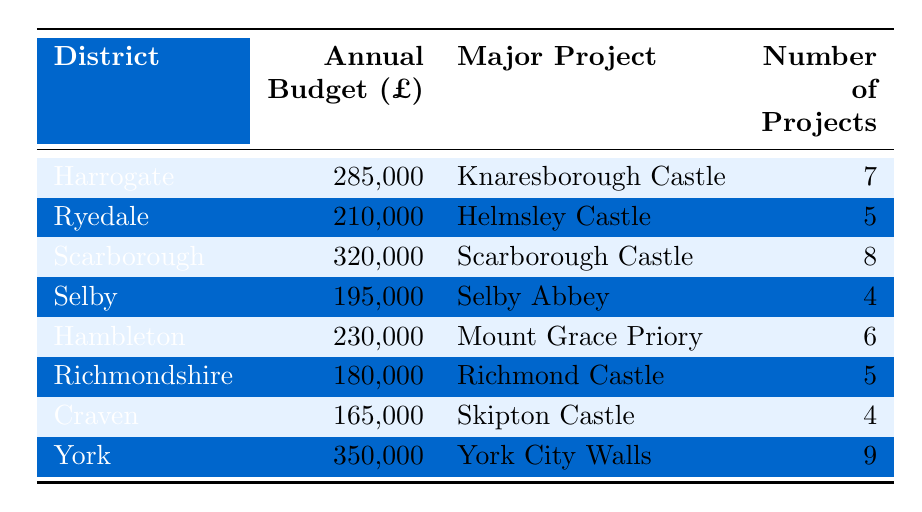What is the annual budget for the Scarborough district? The table lists Scarborough's annual budget as £320,000, which is directly indicated in the corresponding row for this district.
Answer: £320,000 Which district has the highest annual budget? York has the highest annual budget listed at £350,000, which can be confirmed by comparing all the budgets in the table.
Answer: York How many projects are allocated for the Selby district? The number of projects for Selby is stated in the table as 4, which is directly indicated next to the Selby row.
Answer: 4 What is the total annual budget for districts with major projects involving castles? Add the annual budgets of Harrogate (£285,000), Ryedale (£210,000), Scarborough (£320,000), Hambleton (£230,000), Richmondshire (£180,000), Craven (£165,000), and York (£350,000). The total is £285,000 + £210,000 + £320,000 + £230,000 + £180,000 + £165,000 + £350,000 = £1,740,000.
Answer: £1,740,000 Do any districts have the same number of projects? Yes, both Richmondshire and Craven have 5 projects each, as noted in the number of projects column which shows these values for both districts.
Answer: Yes What is the average annual budget for all the districts listed? To find the average, sum the budgets (£285,000 + £210,000 + £320,000 + £195,000 + £230,000 + £180,000 + £165,000 + £350,000 = £1,735,000) and then divide by the number of districts (8). The average annual budget is £1,735,000 / 8 = £216,875.
Answer: £216,875 Which district has the lowest annual budget, and what is it? Looking at the budgets, Richmondshire has the lowest annual budget of £180,000, which is clearly indicated in the row for this district.
Answer: Richmondshire, £180,000 What is the combined number of projects for Harrogate and York? The number of projects for Harrogate is 7 and for York is 9. By adding these together (7 + 9), the combined total is 16.
Answer: 16 Are there more projects in total for districts with the word "Castle" in their major projects than those without? The districts with "Castle" are Harrogate (7), Ryedale (5), Scarborough (8), Hambleton (6), Richmondshire (5), Craven (4), and York (9). The total here is 7 + 5 + 8 + 6 + 5 + 4 + 9 = 44. For districts without "Castle", there's only Selby (4), with no others listed. Hence, 44 > 4.
Answer: Yes Is Selby's major project less significant than those in districts with a budget of over £250,000? Selby's major project is Selby Abbey, which should be considered less significant than both Scarborough Castle (£320,000) and York City Walls (£350,000) because it has a lower budget allocation of £195,000. Thus, comparing the major projects' budgets confirms this.
Answer: Yes 